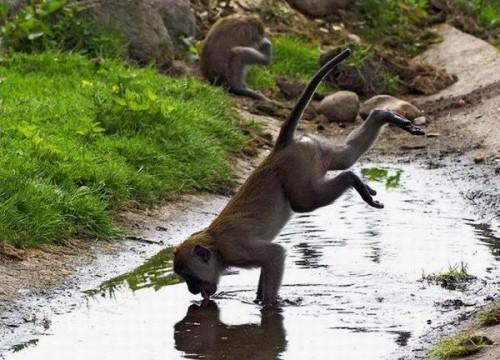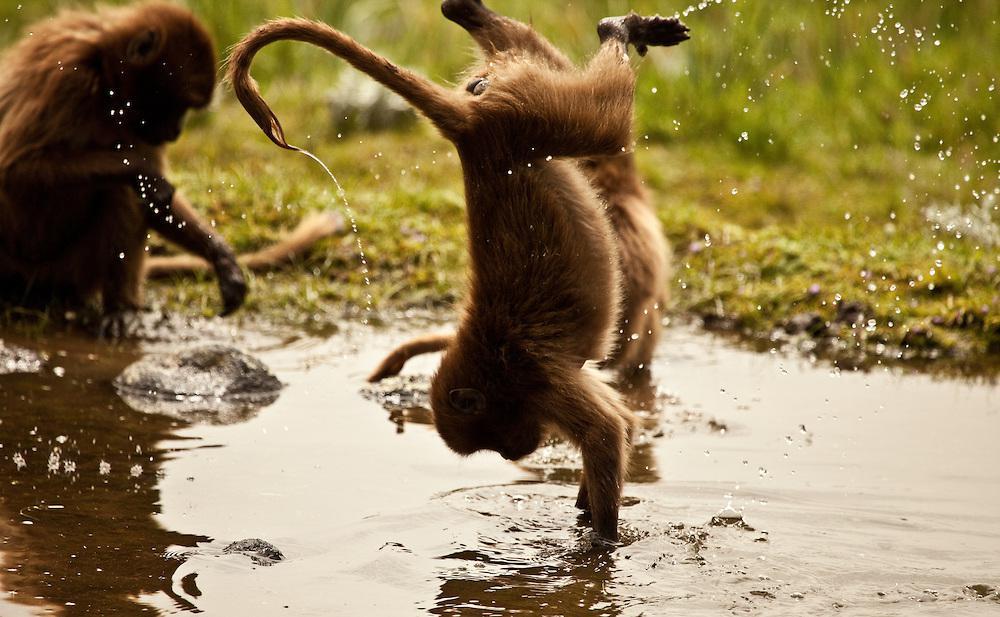The first image is the image on the left, the second image is the image on the right. For the images displayed, is the sentence "An image includes a brown monkey with its arms reaching down below its head and its rear higher than its head." factually correct? Answer yes or no. Yes. The first image is the image on the left, the second image is the image on the right. Considering the images on both sides, is "There are exactly four monkeys." valid? Answer yes or no. No. 